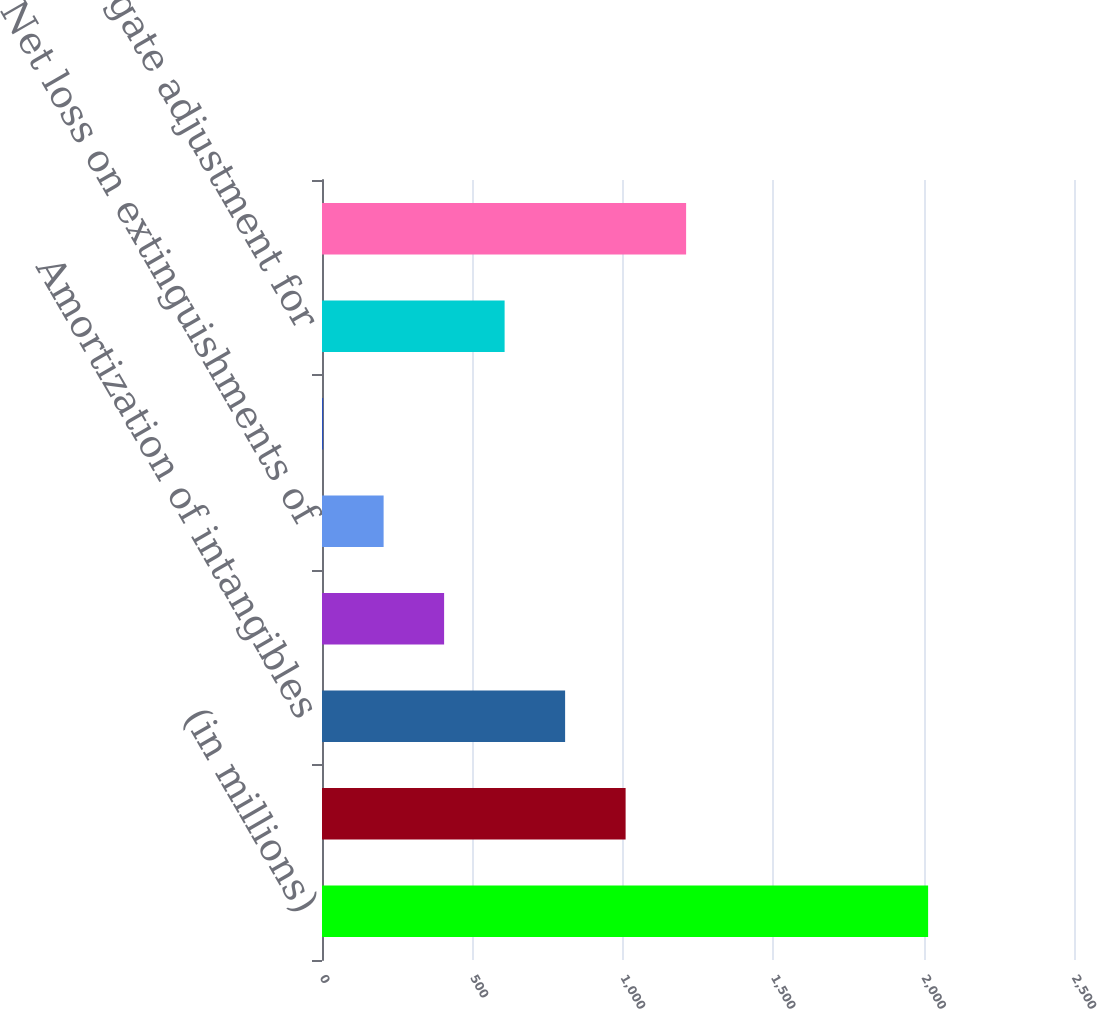<chart> <loc_0><loc_0><loc_500><loc_500><bar_chart><fcel>(in millions)<fcel>Net income<fcel>Amortization of intangibles<fcel>Non-cash equity-based<fcel>Net loss on extinguishments of<fcel>Other adjustments (e)<fcel>Aggregate adjustment for<fcel>Non-GAAP net income (g)<nl><fcel>2015<fcel>1009.35<fcel>808.22<fcel>405.96<fcel>204.83<fcel>3.7<fcel>607.09<fcel>1210.48<nl></chart> 